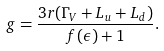Convert formula to latex. <formula><loc_0><loc_0><loc_500><loc_500>g = \frac { 3 r ( \Gamma _ { V } + L _ { u } + L _ { d } ) } { f ( \epsilon ) + 1 } .</formula> 